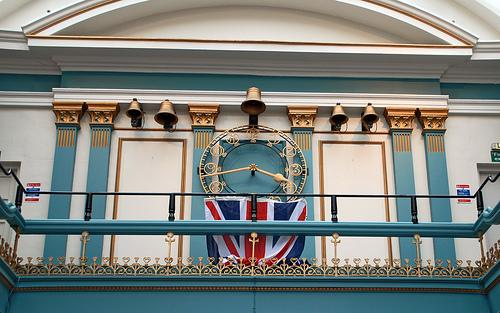How many brass bells can you see in the image? There are five brass bells attached to the wall. What are the colors of the pillars in the image? The pillars are blue and gold, adding a decorative touch to the area. Mention the most interesting object in the image and describe it. The large gold clock on the wall, adorned with golden numbers, and hour and minute hands, displaying a time of about a quarter to four. Choose a unique attribute of the brass bells and describe it. The brass bells are attached to the wall in a row with varying sizes, giving an aesthetic appeal. Can you spot any light on the building and describe its position? Yes, there are multiple lights on the building, mostly positioned near the brass bells on the wall. What time does the clock in the image show? The clock shows a time of around a quarter to four. Provide a brief description of the most prominent object in the image. A large gold clock on the wall, reading about a quarter to four, with a gold hour and minute hand, and gold numbers. What kind of railing is present in the image? A black, blue, and gold railing is present, bordering the balcony. Identify the colors and design of the flag in the image. The flag is blue, white, and red, representing the flag of the United Kingdom. Are there any specific shapes or decorative patterns noticeable in the image? There's a decorative pattern underneath the railing and a rectangle outlined in brass color on a wall. 